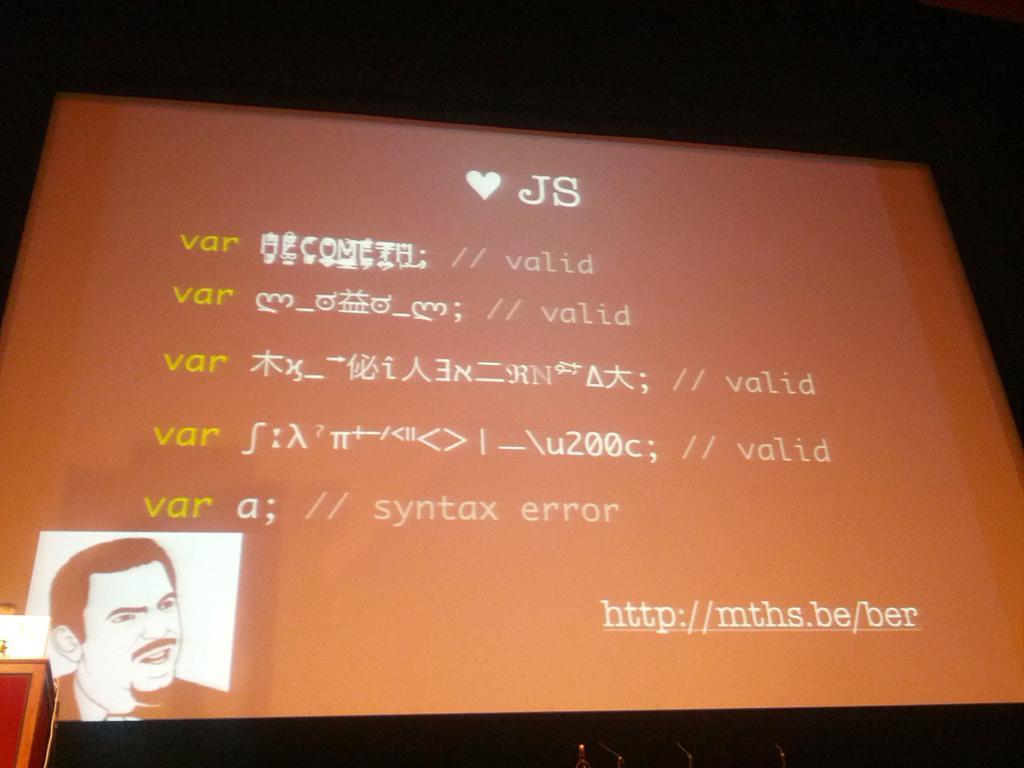How would you summarize this image in a sentence or two? In this picture I can see the projector screen. In the bottom left corner of the screen I can see the person's face. In bottom left corner of the image I can see the speech desk and laptop. At the top I can see the darkness. 